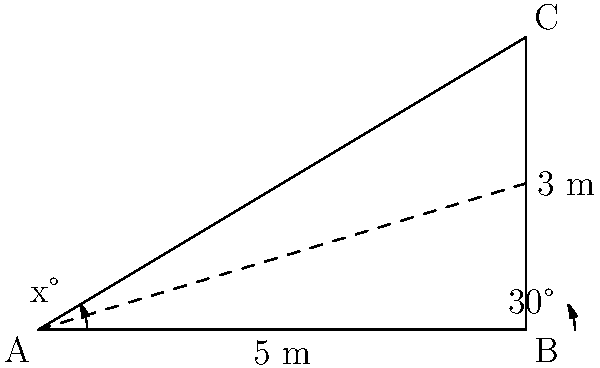A luxury car manufacturer wants to optimize the aerodynamics of their new sports car by adjusting the angle of inclination for the sloped hood. The hood measures 5 meters in length and rises to a height of 3 meters at its highest point. If the optimal angle for air flow is 30° from the horizontal at the front of the hood, what should be the angle of inclination (x°) for the entire hood to achieve this optimal air flow? To solve this problem, we'll follow these steps:

1) First, we need to recognize that we're dealing with a right-angled triangle. The hood forms the hypotenuse of this triangle.

2) We're given the base (5 m) and height (3 m) of this triangle. We can use these to find the angle of inclination.

3) The tangent of an angle in a right-angled triangle is equal to the opposite side divided by the adjacent side.

4) In this case:
   $\tan(x°) = \frac{\text{opposite}}{\text{adjacent}} = \frac{3}{5}$

5) To find x, we need to use the inverse tangent (arctan or tan^(-1)):
   $x° = \tan^{-1}(\frac{3}{5})$

6) Using a calculator or trigonometric tables:
   $x° = \tan^{-1}(0.6) \approx 30.96°$

7) Rounding to the nearest degree:
   $x° \approx 31°$

8) Therefore, the angle of inclination for the entire hood should be approximately 31°.

9) This closely matches the optimal 30° angle at the front of the hood, ensuring smooth air flow over the entire length of the hood.
Answer: 31° 